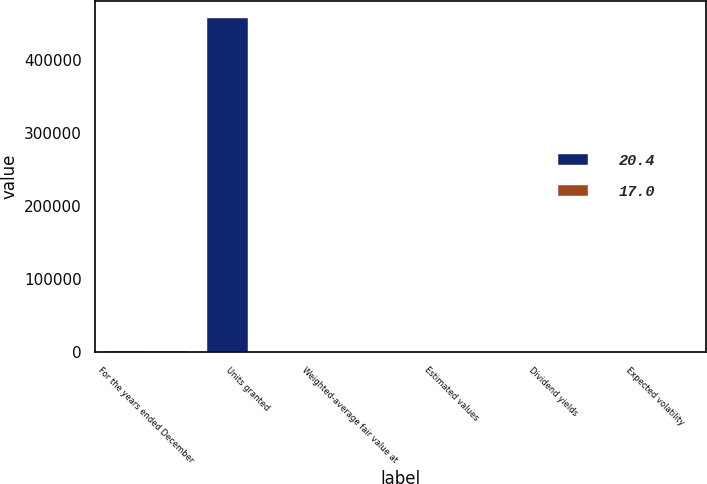Convert chart. <chart><loc_0><loc_0><loc_500><loc_500><stacked_bar_chart><ecel><fcel>For the years ended December<fcel>Units granted<fcel>Weighted-average fair value at<fcel>Estimated values<fcel>Dividend yields<fcel>Expected volatility<nl><fcel>20.4<fcel>2018<fcel>457315<fcel>97.86<fcel>29.17<fcel>2.6<fcel>20.4<nl><fcel>17<fcel>2016<fcel>38.02<fcel>93.55<fcel>38.02<fcel>2.5<fcel>17<nl></chart> 